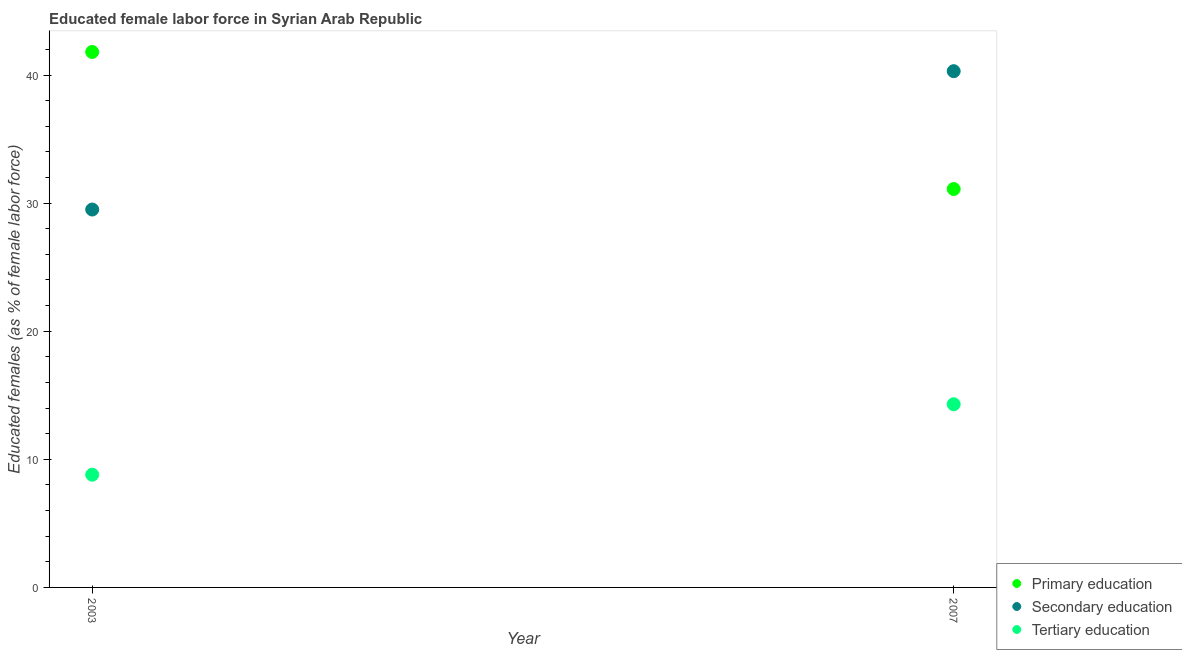Is the number of dotlines equal to the number of legend labels?
Provide a short and direct response. Yes. What is the percentage of female labor force who received secondary education in 2003?
Keep it short and to the point. 29.5. Across all years, what is the maximum percentage of female labor force who received tertiary education?
Provide a succinct answer. 14.3. Across all years, what is the minimum percentage of female labor force who received primary education?
Ensure brevity in your answer.  31.1. In which year was the percentage of female labor force who received primary education maximum?
Provide a succinct answer. 2003. What is the total percentage of female labor force who received tertiary education in the graph?
Provide a short and direct response. 23.1. What is the difference between the percentage of female labor force who received tertiary education in 2003 and that in 2007?
Keep it short and to the point. -5.5. What is the difference between the percentage of female labor force who received primary education in 2003 and the percentage of female labor force who received tertiary education in 2007?
Your answer should be compact. 27.5. What is the average percentage of female labor force who received tertiary education per year?
Provide a succinct answer. 11.55. In the year 2003, what is the difference between the percentage of female labor force who received tertiary education and percentage of female labor force who received secondary education?
Offer a terse response. -20.7. In how many years, is the percentage of female labor force who received tertiary education greater than 36 %?
Offer a very short reply. 0. What is the ratio of the percentage of female labor force who received secondary education in 2003 to that in 2007?
Ensure brevity in your answer.  0.73. In how many years, is the percentage of female labor force who received primary education greater than the average percentage of female labor force who received primary education taken over all years?
Keep it short and to the point. 1. Is it the case that in every year, the sum of the percentage of female labor force who received primary education and percentage of female labor force who received secondary education is greater than the percentage of female labor force who received tertiary education?
Provide a succinct answer. Yes. Is the percentage of female labor force who received tertiary education strictly less than the percentage of female labor force who received secondary education over the years?
Provide a short and direct response. Yes. How many dotlines are there?
Provide a succinct answer. 3. How many years are there in the graph?
Ensure brevity in your answer.  2. Does the graph contain any zero values?
Offer a terse response. No. Does the graph contain grids?
Your response must be concise. No. Where does the legend appear in the graph?
Offer a very short reply. Bottom right. How many legend labels are there?
Provide a succinct answer. 3. How are the legend labels stacked?
Ensure brevity in your answer.  Vertical. What is the title of the graph?
Make the answer very short. Educated female labor force in Syrian Arab Republic. What is the label or title of the Y-axis?
Ensure brevity in your answer.  Educated females (as % of female labor force). What is the Educated females (as % of female labor force) of Primary education in 2003?
Your answer should be compact. 41.8. What is the Educated females (as % of female labor force) in Secondary education in 2003?
Offer a very short reply. 29.5. What is the Educated females (as % of female labor force) of Tertiary education in 2003?
Offer a terse response. 8.8. What is the Educated females (as % of female labor force) in Primary education in 2007?
Offer a terse response. 31.1. What is the Educated females (as % of female labor force) of Secondary education in 2007?
Your response must be concise. 40.3. What is the Educated females (as % of female labor force) in Tertiary education in 2007?
Make the answer very short. 14.3. Across all years, what is the maximum Educated females (as % of female labor force) of Primary education?
Offer a terse response. 41.8. Across all years, what is the maximum Educated females (as % of female labor force) of Secondary education?
Your answer should be very brief. 40.3. Across all years, what is the maximum Educated females (as % of female labor force) of Tertiary education?
Offer a very short reply. 14.3. Across all years, what is the minimum Educated females (as % of female labor force) of Primary education?
Keep it short and to the point. 31.1. Across all years, what is the minimum Educated females (as % of female labor force) in Secondary education?
Your answer should be very brief. 29.5. Across all years, what is the minimum Educated females (as % of female labor force) in Tertiary education?
Offer a very short reply. 8.8. What is the total Educated females (as % of female labor force) in Primary education in the graph?
Keep it short and to the point. 72.9. What is the total Educated females (as % of female labor force) in Secondary education in the graph?
Offer a very short reply. 69.8. What is the total Educated females (as % of female labor force) of Tertiary education in the graph?
Keep it short and to the point. 23.1. What is the difference between the Educated females (as % of female labor force) of Primary education in 2003 and that in 2007?
Make the answer very short. 10.7. What is the difference between the Educated females (as % of female labor force) in Tertiary education in 2003 and that in 2007?
Your response must be concise. -5.5. What is the difference between the Educated females (as % of female labor force) of Primary education in 2003 and the Educated females (as % of female labor force) of Tertiary education in 2007?
Your answer should be very brief. 27.5. What is the difference between the Educated females (as % of female labor force) of Secondary education in 2003 and the Educated females (as % of female labor force) of Tertiary education in 2007?
Make the answer very short. 15.2. What is the average Educated females (as % of female labor force) in Primary education per year?
Your answer should be very brief. 36.45. What is the average Educated females (as % of female labor force) in Secondary education per year?
Keep it short and to the point. 34.9. What is the average Educated females (as % of female labor force) of Tertiary education per year?
Offer a terse response. 11.55. In the year 2003, what is the difference between the Educated females (as % of female labor force) in Primary education and Educated females (as % of female labor force) in Secondary education?
Your answer should be compact. 12.3. In the year 2003, what is the difference between the Educated females (as % of female labor force) of Primary education and Educated females (as % of female labor force) of Tertiary education?
Offer a terse response. 33. In the year 2003, what is the difference between the Educated females (as % of female labor force) in Secondary education and Educated females (as % of female labor force) in Tertiary education?
Your response must be concise. 20.7. In the year 2007, what is the difference between the Educated females (as % of female labor force) in Primary education and Educated females (as % of female labor force) in Tertiary education?
Provide a short and direct response. 16.8. What is the ratio of the Educated females (as % of female labor force) of Primary education in 2003 to that in 2007?
Offer a very short reply. 1.34. What is the ratio of the Educated females (as % of female labor force) of Secondary education in 2003 to that in 2007?
Give a very brief answer. 0.73. What is the ratio of the Educated females (as % of female labor force) in Tertiary education in 2003 to that in 2007?
Your answer should be compact. 0.62. What is the difference between the highest and the second highest Educated females (as % of female labor force) in Primary education?
Your answer should be very brief. 10.7. What is the difference between the highest and the second highest Educated females (as % of female labor force) in Secondary education?
Offer a very short reply. 10.8. What is the difference between the highest and the lowest Educated females (as % of female labor force) of Primary education?
Ensure brevity in your answer.  10.7. What is the difference between the highest and the lowest Educated females (as % of female labor force) of Secondary education?
Your response must be concise. 10.8. 